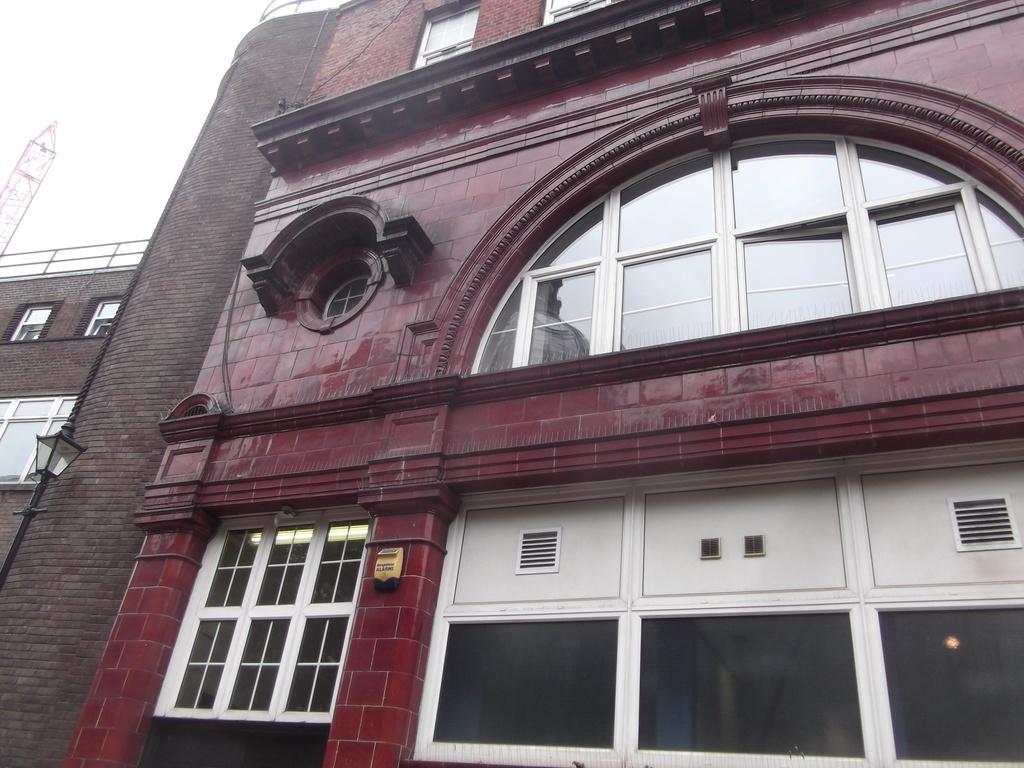How would you summarize this image in a sentence or two? This picture might be taken from outside of the building. In this image, we can see a building, glass window. On the left side, we can see a brick wall, street light, pole. At the top, we can see a sky. 